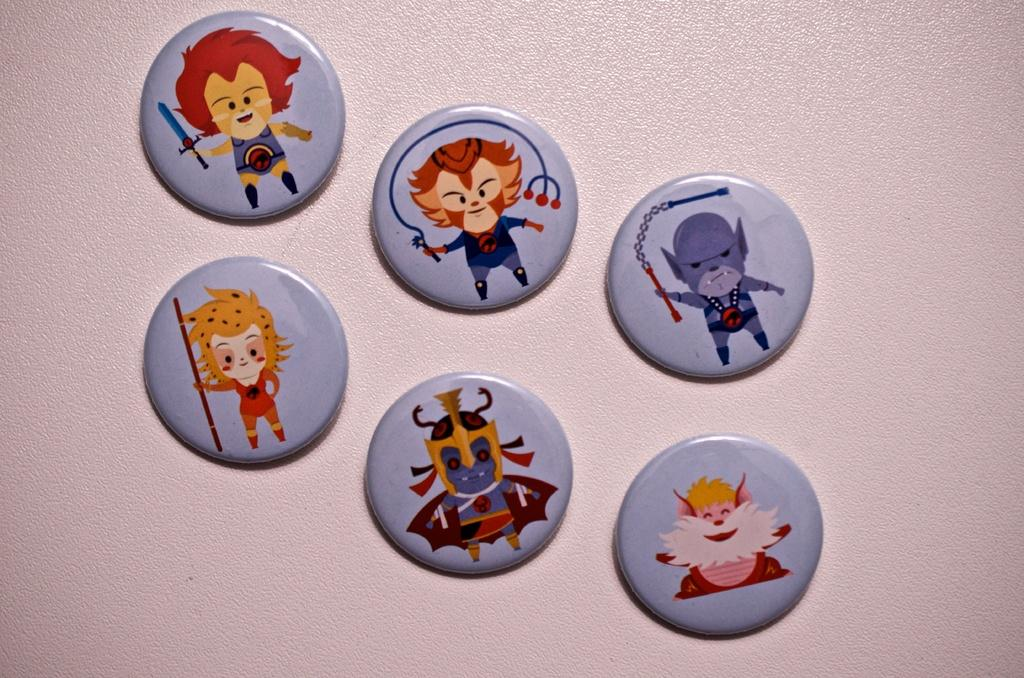How many coins are visible in the image? There are six gray coins in the image. What distinguishes each coin from the others? Each coin has a different painting. How are the coins arranged in the image? The coins are pasted on a surface. What is the color of the background in the image? The background color is pink. Can you tell me how many zebras are depicted on the coins? There are no zebras depicted on the coins; each coin has a different painting, but none of them feature a zebra. What is the donkey's role in the image? There is no donkey present in the image. 